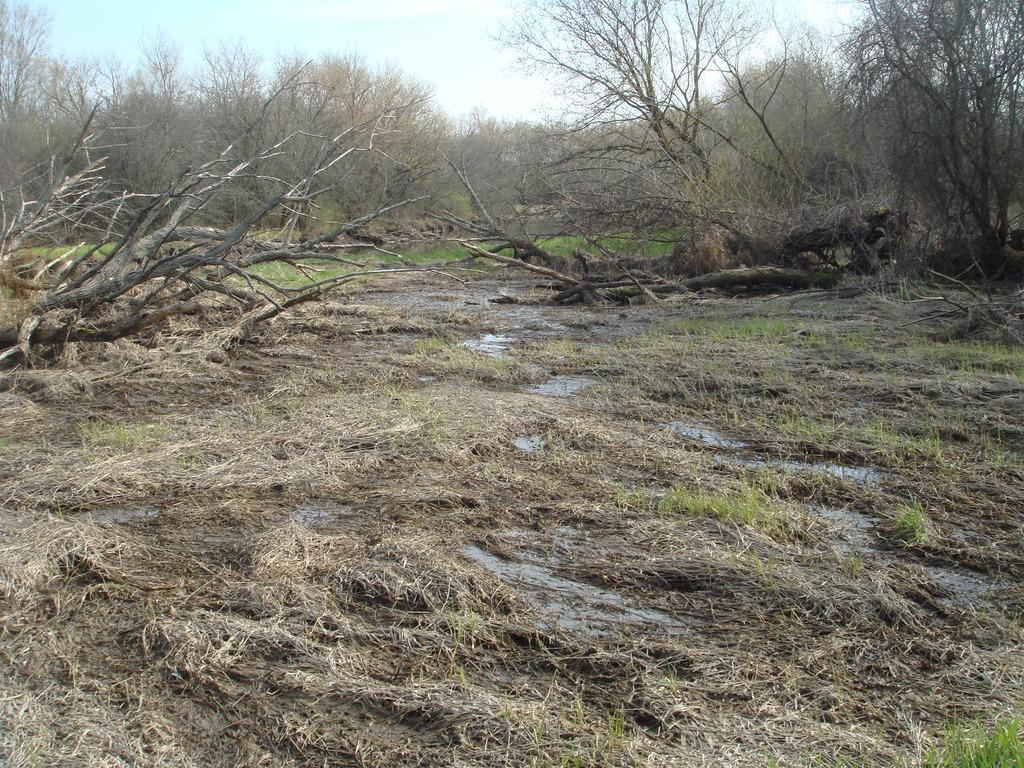What type of terrain is depicted in the image? There is mud, grass, and water on the ground in the image. What can be seen in the background of the image? There are trees and the sky visible in the background of the image. What type of stocking is hanging from the tree in the image? There is no stocking hanging from the tree in the image. What emotion is the mud feeling in the image? The mud does not have emotions, as it is an inanimate object. 